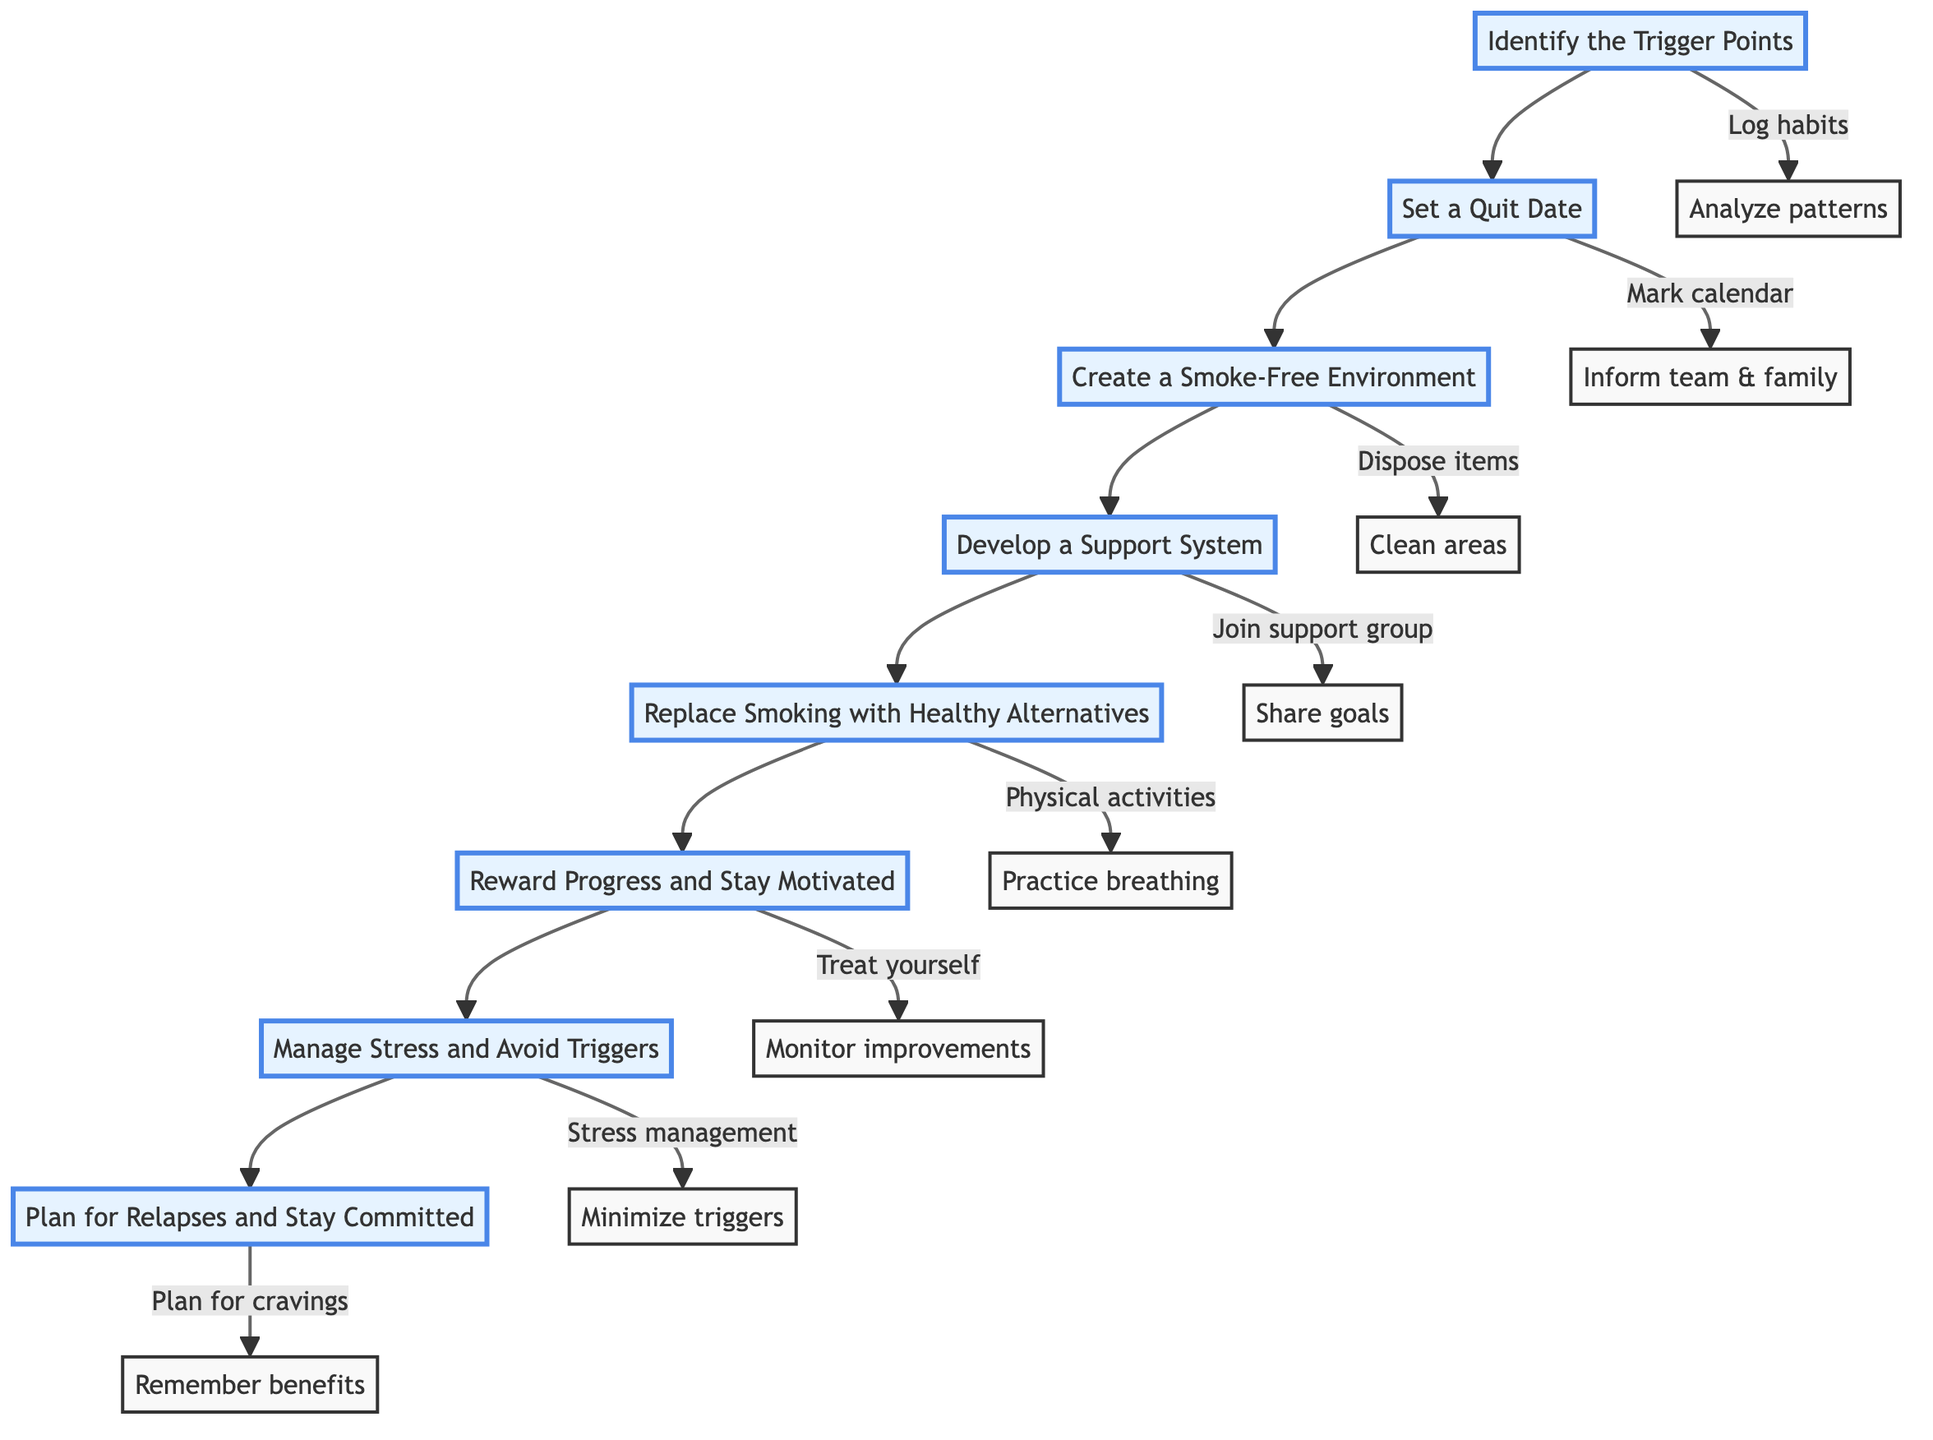What is the first step in the process? The first step in the flow chart is indicated by the node labeled "Identify the Trigger Points." This can be seen as the starting point of the diagram, where the process begins.
Answer: Identify the Trigger Points How many total steps are there in this smoke-free routine? By counting the nodes in the flow chart, there are a total of eight distinct steps listed from "Identify the Trigger Points" to "Plan for Relapses and Stay Committed."
Answer: Eight Which step comes after "Set a Quit Date"? The flow chart shows that the step following "Set a Quit Date" is "Create a Smoke-Free Environment." This is a direct connection indicated by the arrows in the flowchart.
Answer: Create a Smoke-Free Environment What is one action associated with "Develop a Support System"? One action related to "Develop a Support System" is to "Join a support group like Nicotine Anonymous." This action is clearly outlined below that step in the diagram.
Answer: Join a support group like Nicotine Anonymous Which two steps involve replacing or minimizing items? The steps that focus on replacing or minimizing items are "Create a Smoke-Free Environment" and "Manage Stress and Avoid Triggers." These steps involve disposing of smoking-related items and minimizing exposure to triggers, respectively.
Answer: Create a Smoke-Free Environment and Manage Stress and Avoid Triggers What do you need to do after "Reward Progress and Stay Motivated"? Following "Reward Progress and Stay Motivated," the next step in the sequence is "Manage Stress and Avoid Triggers." This indicates the order of actions to be taken as part of the overall routine.
Answer: Manage Stress and Avoid Triggers What is the last action described in the flowchart? The last action described in the flowchart is to "Remember benefits," which is associated with the step "Plan for Relapses and Stay Committed." This indicates the importance of recalling the advantages of quitting smoking when facing challenges.
Answer: Remember benefits What should you do on the quit date according to the instructions? According to the instructions, on the quit date, you should "Inform your team and family about your quit date for support." This emphasizes the need for communication and support during the quitting process.
Answer: Inform your team and family about your quit date for support Which step involves practicing techniques for stress management? The step that involves practicing techniques for stress management is "Manage Stress and Avoid Triggers." This step specifically lists techniques such as yoga and progressive muscle relaxation as actions to be taken.
Answer: Manage Stress and Avoid Triggers 